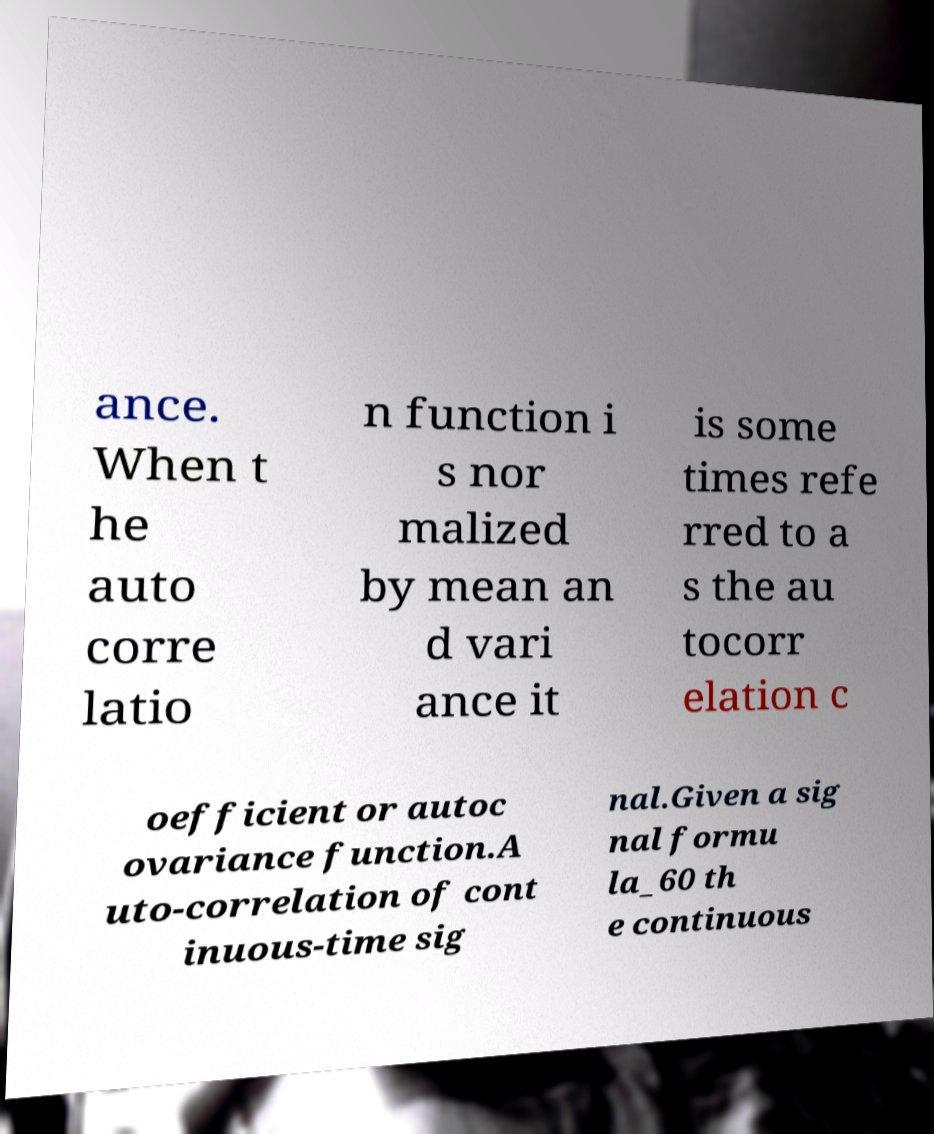Could you extract and type out the text from this image? ance. When t he auto corre latio n function i s nor malized by mean an d vari ance it is some times refe rred to a s the au tocorr elation c oefficient or autoc ovariance function.A uto-correlation of cont inuous-time sig nal.Given a sig nal formu la_60 th e continuous 